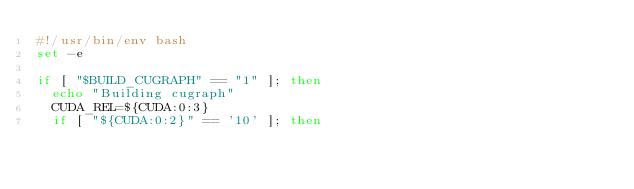<code> <loc_0><loc_0><loc_500><loc_500><_Bash_>#!/usr/bin/env bash
set -e

if [ "$BUILD_CUGRAPH" == "1" ]; then
  echo "Building cugraph"
  CUDA_REL=${CUDA:0:3}
  if [ "${CUDA:0:2}" == '10' ]; then</code> 